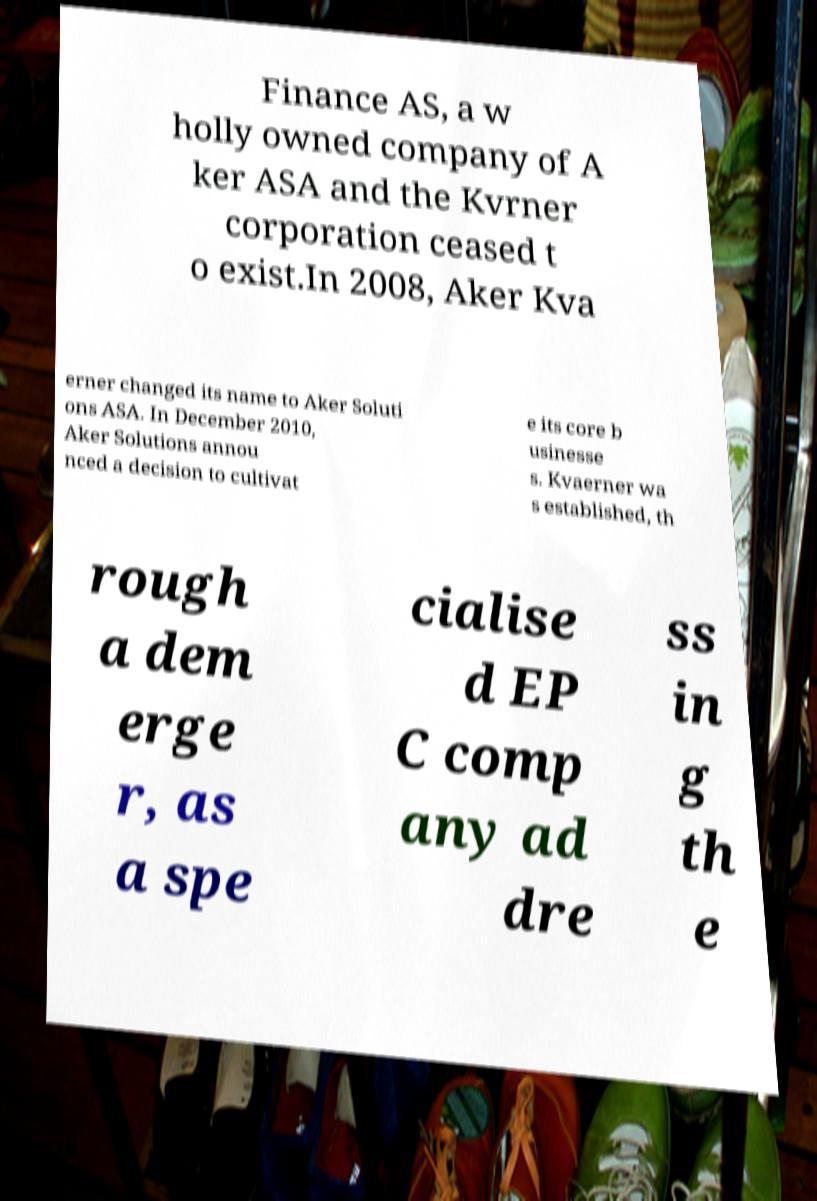Please read and relay the text visible in this image. What does it say? Finance AS, a w holly owned company of A ker ASA and the Kvrner corporation ceased t o exist.In 2008, Aker Kva erner changed its name to Aker Soluti ons ASA. In December 2010, Aker Solutions annou nced a decision to cultivat e its core b usinesse s. Kvaerner wa s established, th rough a dem erge r, as a spe cialise d EP C comp any ad dre ss in g th e 